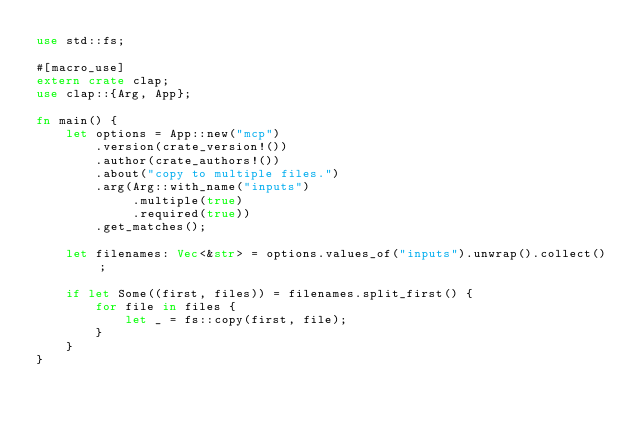<code> <loc_0><loc_0><loc_500><loc_500><_Rust_>use std::fs;

#[macro_use]
extern crate clap;
use clap::{Arg, App};

fn main() {
    let options = App::new("mcp")
        .version(crate_version!())
        .author(crate_authors!())
        .about("copy to multiple files.")
        .arg(Arg::with_name("inputs")
             .multiple(true)
             .required(true))
        .get_matches();

    let filenames: Vec<&str> = options.values_of("inputs").unwrap().collect();

    if let Some((first, files)) = filenames.split_first() {
        for file in files {
            let _ = fs::copy(first, file);
        }
    }
}
</code> 